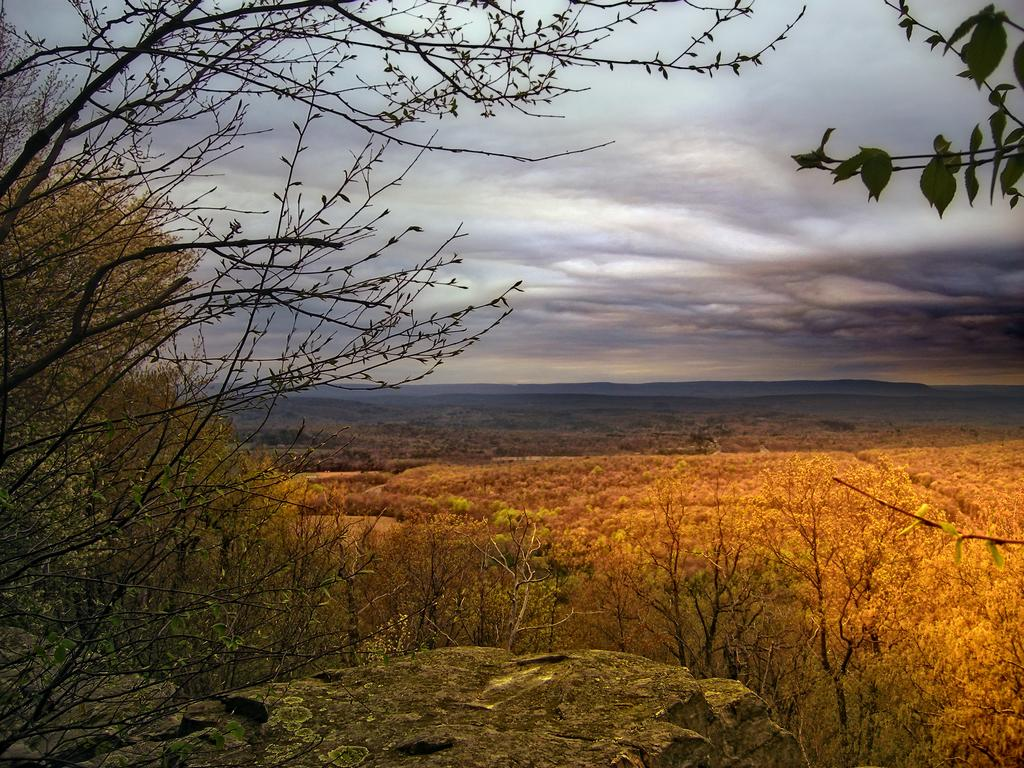What type of vegetation can be seen in the image? There are trees in the image. What type of landscape feature is present in the image? There are hills in the image. What is visible in the background of the image? The sky is visible in the background of the image. What type of railway can be seen in the image? There is no railway present in the image; it features trees and hills. How do the trees and hills smell in the image? The image is a visual representation, and smells cannot be determined from a visual image. 